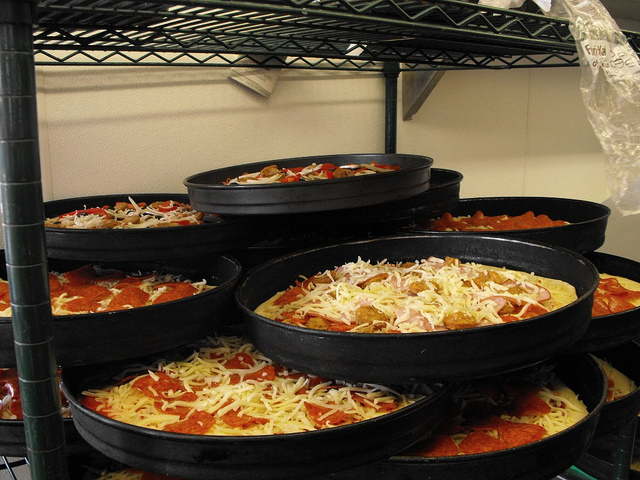Please provide the bounding box coordinate of the region this sentence describes: closest full pizza visible. [0.4, 0.53, 0.9, 0.64] Please provide a short description for this region: [0.52, 0.68, 0.95, 0.88]. Bottom pizza pan on right. Please provide the bounding box coordinate of the region this sentence describes: the pizza closet to the front with pepperoni. [0.1, 0.64, 0.69, 0.81] Please provide a short description for this region: [0.28, 0.36, 0.68, 0.46]. Highest level pizza pan. Please provide the bounding box coordinate of the region this sentence describes: pizza closest to us. [0.1, 0.64, 0.69, 0.81] Please provide the bounding box coordinate of the region this sentence describes: low pizza beneath two. [0.52, 0.68, 0.95, 0.88] Please provide the bounding box coordinate of the region this sentence describes: third from bottom pizza. [0.4, 0.53, 0.9, 0.64] 